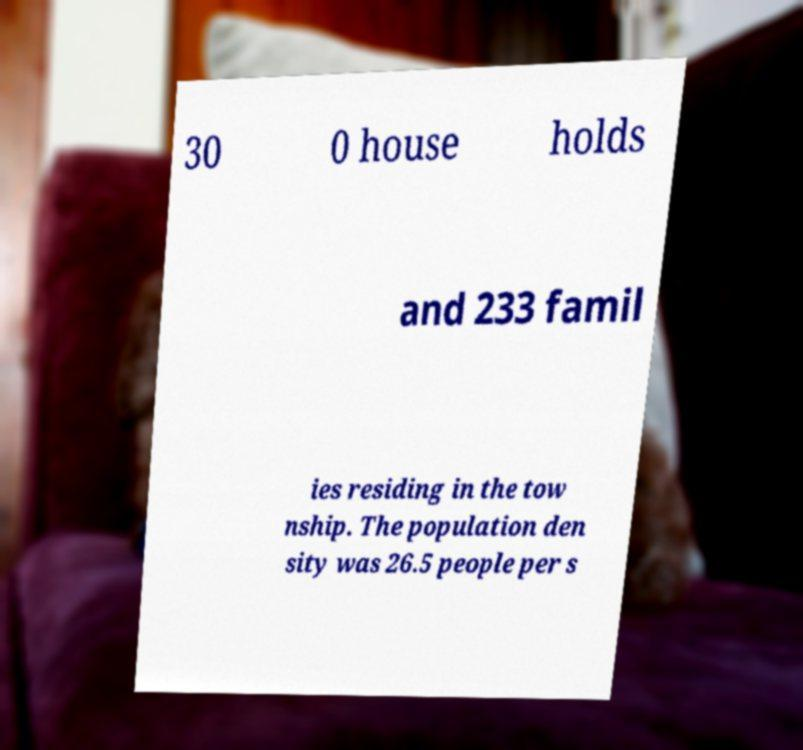Can you read and provide the text displayed in the image?This photo seems to have some interesting text. Can you extract and type it out for me? 30 0 house holds and 233 famil ies residing in the tow nship. The population den sity was 26.5 people per s 